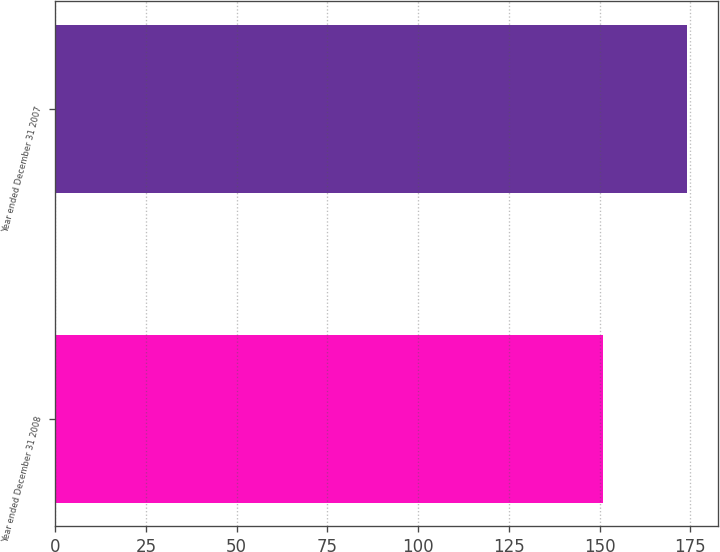Convert chart to OTSL. <chart><loc_0><loc_0><loc_500><loc_500><bar_chart><fcel>Year ended December 31 2008<fcel>Year ended December 31 2007<nl><fcel>151<fcel>174<nl></chart> 